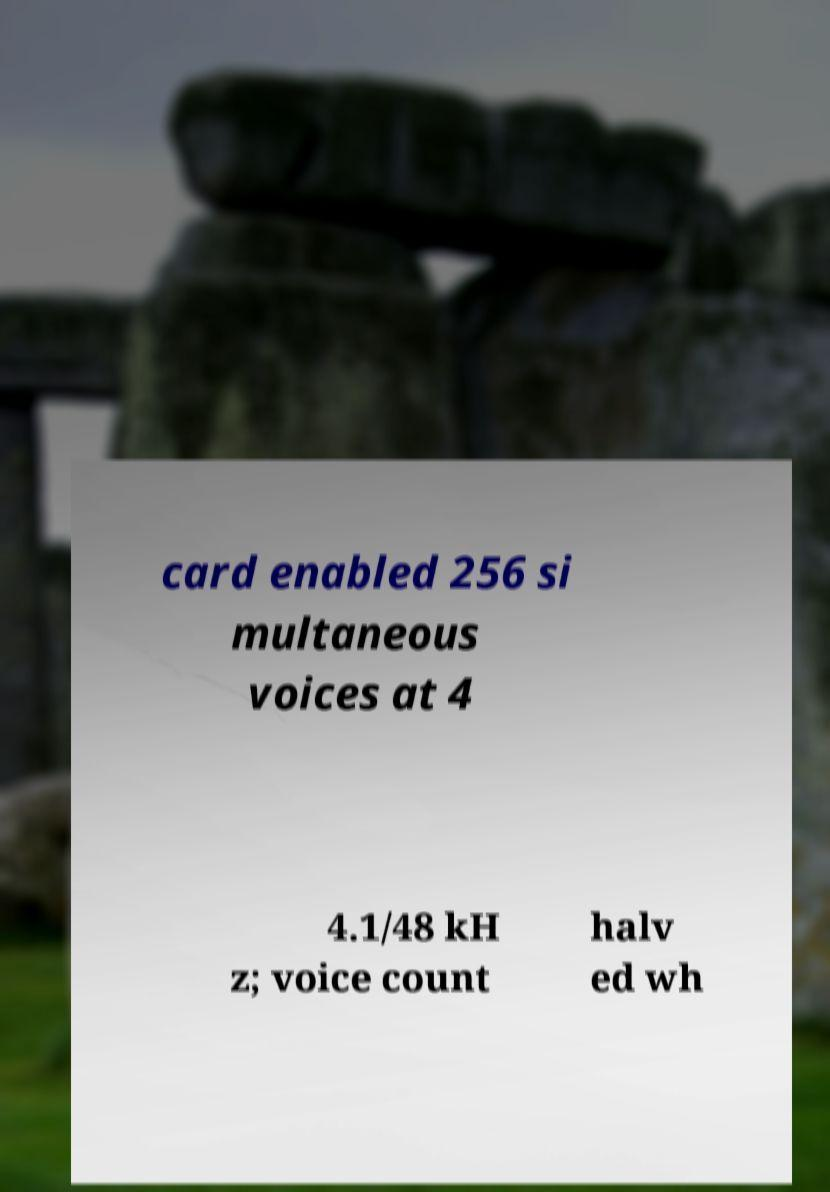Could you extract and type out the text from this image? card enabled 256 si multaneous voices at 4 4.1/48 kH z; voice count halv ed wh 